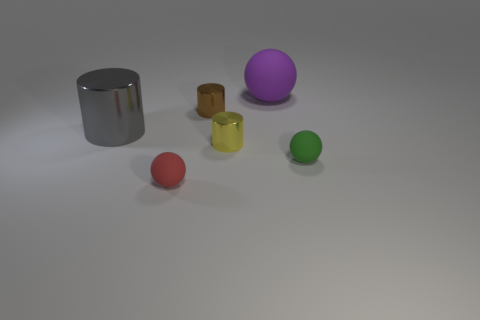There is a sphere that is both on the right side of the brown thing and in front of the big matte ball; what is its material?
Provide a short and direct response. Rubber. What is the color of the large metal cylinder?
Make the answer very short. Gray. Is the number of matte objects that are in front of the tiny yellow shiny cylinder greater than the number of big metal cylinders that are to the right of the gray metallic cylinder?
Provide a succinct answer. Yes. There is a tiny matte ball behind the tiny red rubber ball; what is its color?
Provide a succinct answer. Green. There is a purple ball behind the tiny brown cylinder; is its size the same as the rubber ball on the left side of the tiny brown thing?
Your answer should be very brief. No. How many things are either big rubber spheres or small brown metallic things?
Ensure brevity in your answer.  2. There is a big object that is on the right side of the rubber thing that is on the left side of the tiny yellow object; what is its material?
Keep it short and to the point. Rubber. What number of big gray things are the same shape as the yellow metallic thing?
Offer a terse response. 1. Are there any cylinders of the same color as the large metallic thing?
Provide a short and direct response. No. What number of objects are either balls behind the tiny green matte object or small objects that are on the right side of the small brown metallic cylinder?
Make the answer very short. 3. 